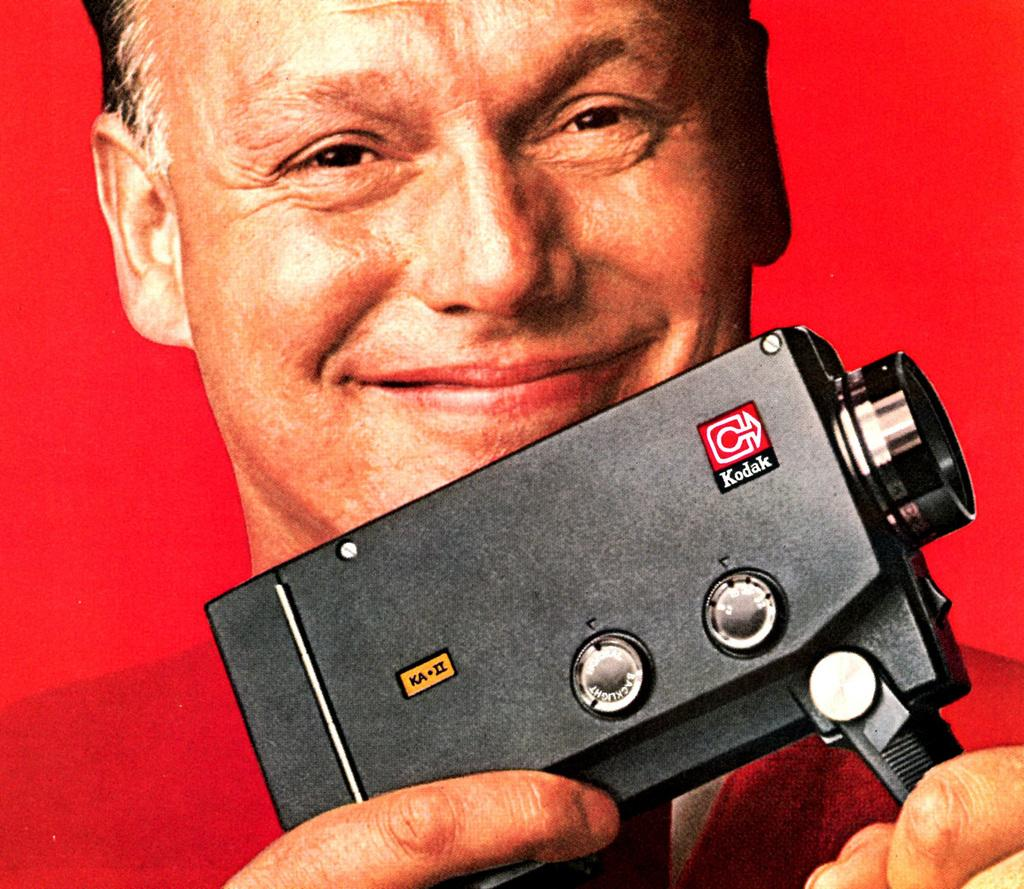What color is the background of the image? The background of the image is red. Who is present in the image? There is a man in the image. What is the man's facial expression? The man has a smiling face. What is the man holding in his hands? The man is holding a camera in his hands. How many legs does the carriage have in the image? There is no carriage present in the image. What type of nut is the man cracking with his teeth in the image? There is no nut or any activity involving nuts in the image. 